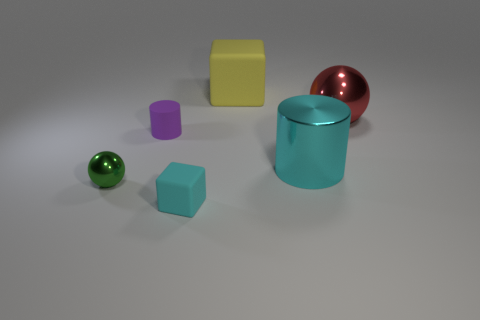Add 3 small yellow shiny things. How many objects exist? 9 Subtract all cylinders. How many objects are left? 4 Add 3 green cylinders. How many green cylinders exist? 3 Subtract 0 gray balls. How many objects are left? 6 Subtract all small purple cylinders. Subtract all small purple things. How many objects are left? 4 Add 5 cylinders. How many cylinders are left? 7 